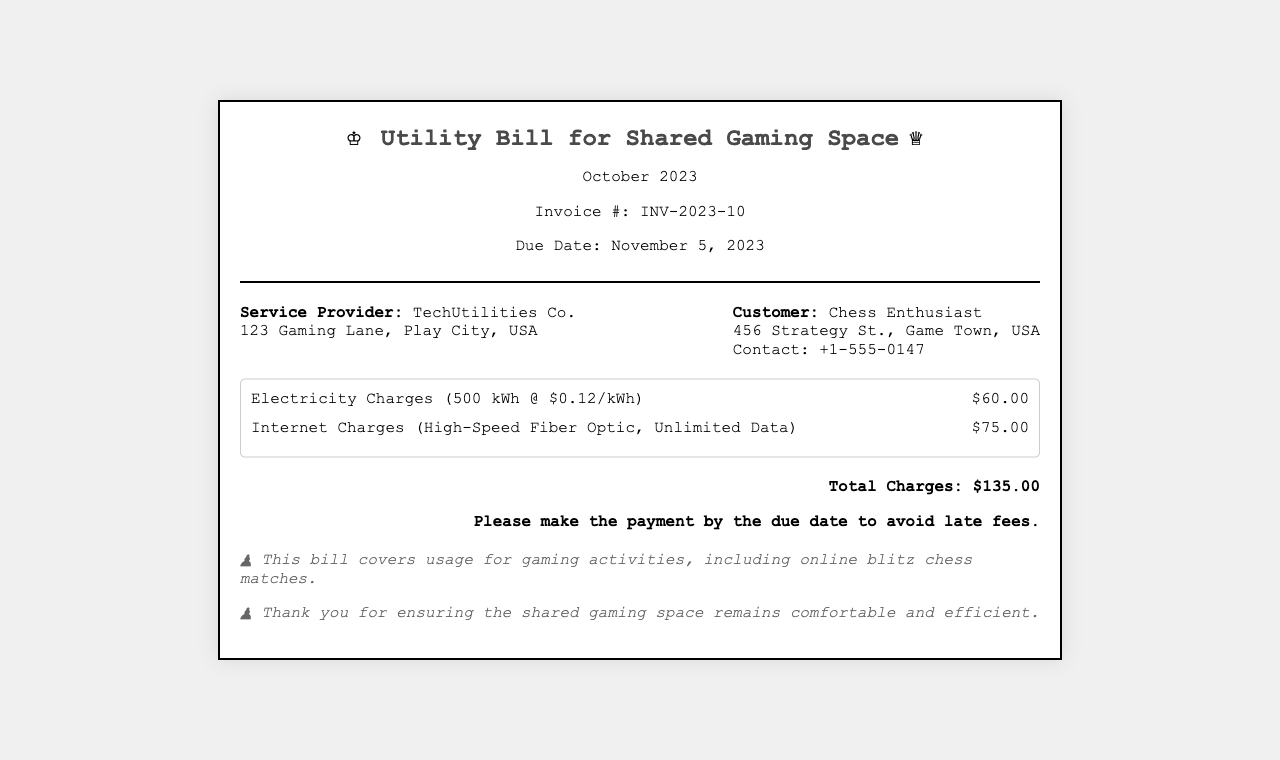What is the service provider's name? The service provider's name is listed in the billing details section of the document.
Answer: TechUtilities Co What is the due date for the invoice? The due date is specified in the header section of the document.
Answer: November 5, 2023 What are the electricity charges? The electricity charges are detailed in the charges section of the document.
Answer: $60.00 How many kilowatt-hours were used? The usage of electricity is specified next to the charges in the document.
Answer: 500 kWh What is the total amount due? The total amount due is summarized in the summary section of the document.
Answer: $135.00 What type of internet service is provided? The type of internet service is mentioned in the charges section of the document.
Answer: High-Speed Fiber Optic, Unlimited Data How much is charged per kilowatt-hour? The charge per kilowatt-hour is mentioned alongside the electricity charges.
Answer: $0.12/kWh What is the customer's contact number? The customer's contact number is listed in the billing details section of the document.
Answer: +1-555-0147 